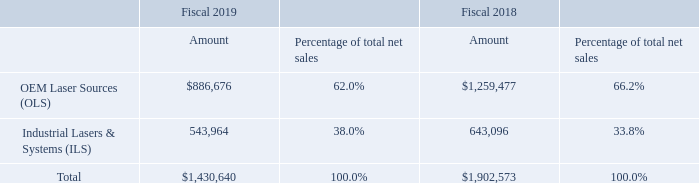Segments
We are organized into two reportable operating segments: OLS and ILS. While both segments deliver cost-effective, highly reliable photonics solutions, OLS is focused on high performance laser sources and complex optical sub-systems, typically used in microelectronics manufacturing, medical diagnostics and therapeutic applications, as well as in scientific research. ILS delivers high performance laser sources, sub-systems and tools primarily used for industrial laser materials processing, serving important end markets like automotive, machine tool, consumer goods and medical device manufacturing.
The following table sets forth, for the periods indicated, the amount of net sales and their relative percentages of total net sales by segment (dollars in thousands):
Net sales for fiscal 2019 decreased $471.9 million, or 25%, compared to fiscal 2018, with decreases of $372.8 million, or 30%, in our OLS segment and decreases of $99.1 million, or 15%, in our ILS segment. The fiscal 2019 decreases in both OLS and ILS segment sales included decreases due to the unfavorable impact of foreign exchange rates.
The decrease in our OLS segment sales in fiscal 2019 was primarily due to weaker demand resulting in lower shipments of ELA tools used in the flat panel display market and lower revenues from consumable service parts.
The decrease in our ILS segment sales from fiscal 2018 to fiscal 2019 was primarily due to lower sales for materials processing and microelectronics applications, partially offset by higher sales for medical and military applications within the OEM components and instrumentation market.
What led to the decrease in the OLS segment in 2019? Primarily due to weaker demand resulting in lower shipments of ela tools used in the flat panel display market and lower revenues from consumable service parts. What led to the decrease in the ILS segment in 2019? Primarily due to lower sales for materials processing and microelectronics applications, partially offset by higher sales for medical and military applications within the oem components and instrumentation market. In which years was the operating segment data provided? 2019, 2018. In which year was ILS a higher percentage of total net sales? 38.0%>33.8%
Answer: 2019. What was the average amount of net sales for OLS in 2018 and 2019?
Answer scale should be: thousand. (886,676+1,259,477)/2
Answer: 1073076.5. What was the average amount of net sales for ILS in 2018 and 2019?
Answer scale should be: thousand. (543,964+643,096)/2
Answer: 593530. 